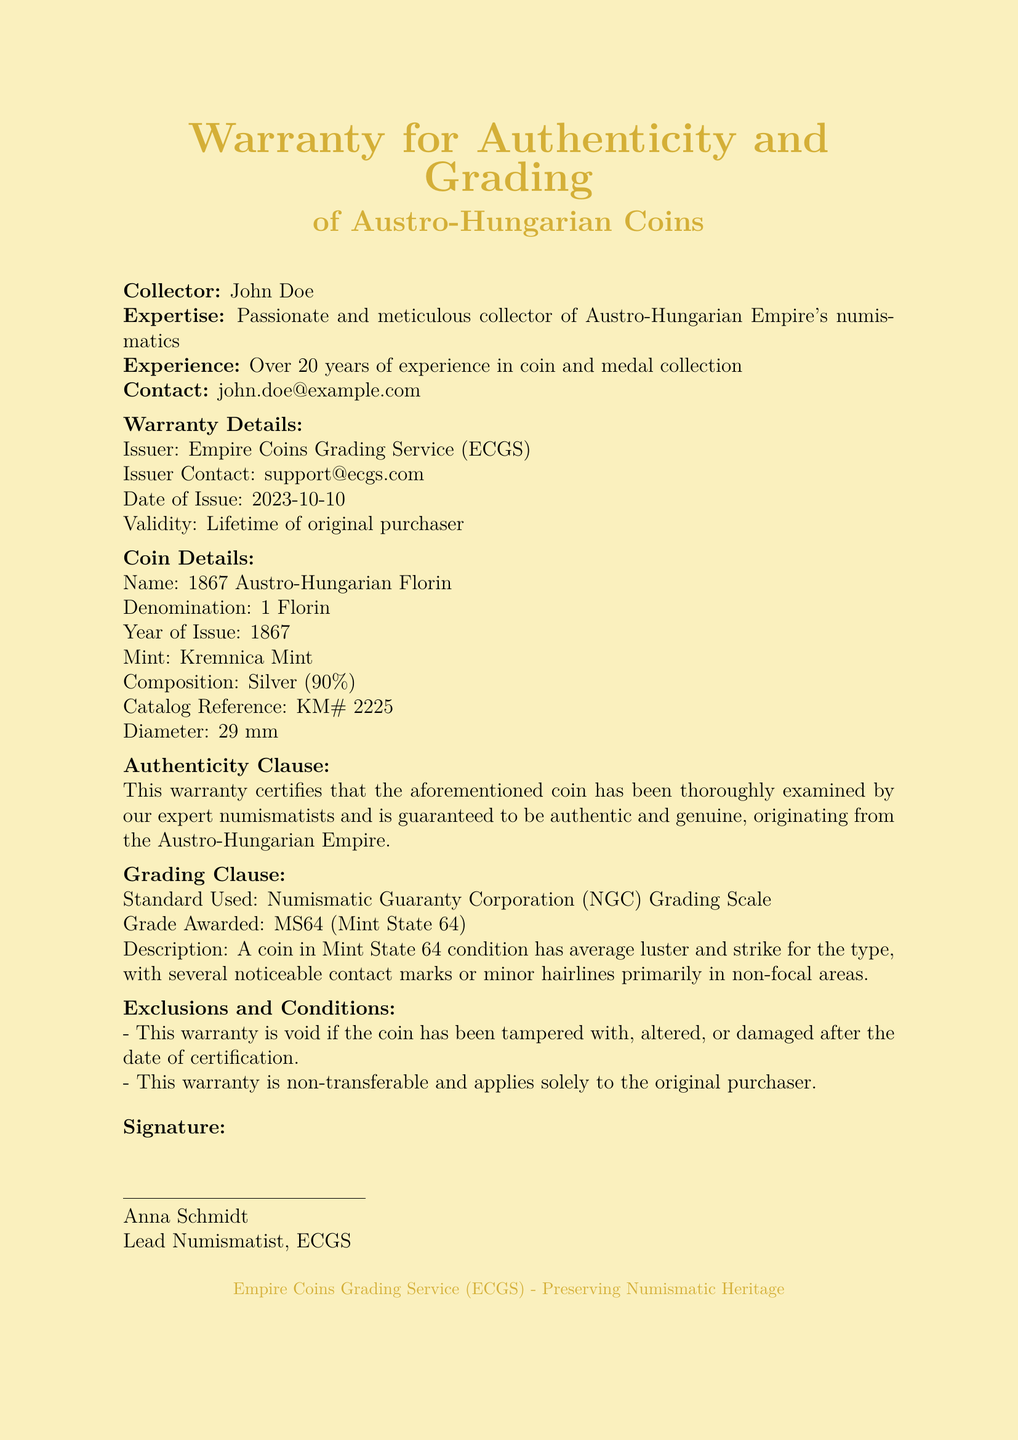What is the name of the coin? The name of the coin is specified in the document under "Coin Details."
Answer: 1867 Austro-Hungarian Florin Who issued the warranty? The issuer is identified in the document under "Warranty Details."
Answer: Empire Coins Grading Service (ECGS) What is the grade awarded to the coin? The grade is provided in the "Grading Clause."
Answer: MS64 What is the composition of the coin? The composition of the coin is mentioned in the "Coin Details."
Answer: Silver (90%) What is the warranty validity period? The validity is stated under "Warranty Details."
Answer: Lifetime of original purchaser Who is the contact person for the issuer? The contact person is noted in the "Warranty Details."
Answer: support@ecgs.com What happens if the coin is altered? The consequence is mentioned in the "Exclusions and Conditions."
Answer: Warranty is void When was the warranty issued? The issue date is indicated in the "Warranty Details."
Answer: 2023-10-10 What grading standard is used? The standard is referenced in the "Grading Clause."
Answer: Numismatic Guaranty Corporation (NGC) Grading Scale 